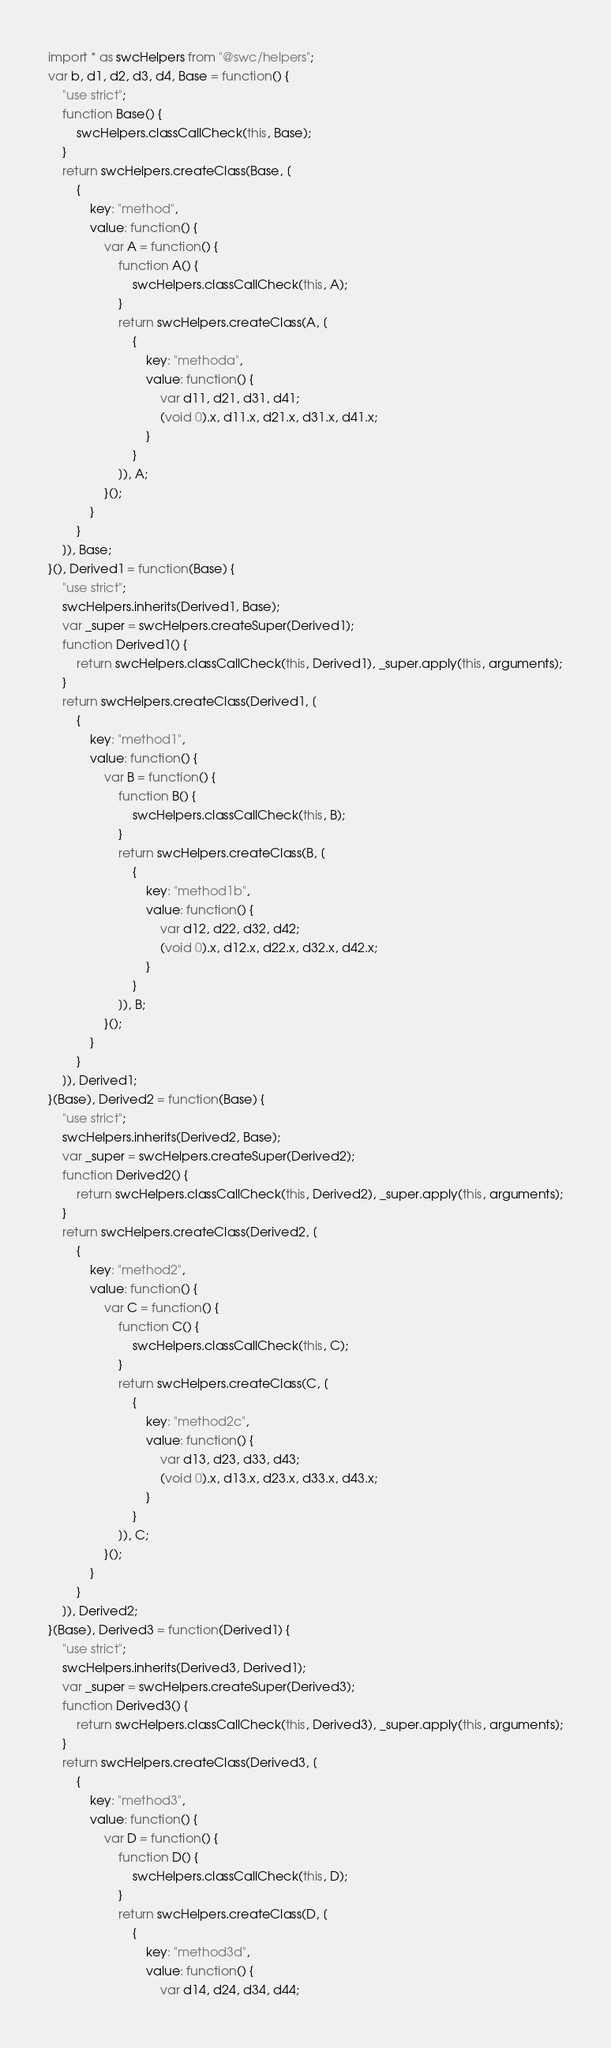Convert code to text. <code><loc_0><loc_0><loc_500><loc_500><_JavaScript_>import * as swcHelpers from "@swc/helpers";
var b, d1, d2, d3, d4, Base = function() {
    "use strict";
    function Base() {
        swcHelpers.classCallCheck(this, Base);
    }
    return swcHelpers.createClass(Base, [
        {
            key: "method",
            value: function() {
                var A = function() {
                    function A() {
                        swcHelpers.classCallCheck(this, A);
                    }
                    return swcHelpers.createClass(A, [
                        {
                            key: "methoda",
                            value: function() {
                                var d11, d21, d31, d41;
                                (void 0).x, d11.x, d21.x, d31.x, d41.x;
                            }
                        }
                    ]), A;
                }();
            }
        }
    ]), Base;
}(), Derived1 = function(Base) {
    "use strict";
    swcHelpers.inherits(Derived1, Base);
    var _super = swcHelpers.createSuper(Derived1);
    function Derived1() {
        return swcHelpers.classCallCheck(this, Derived1), _super.apply(this, arguments);
    }
    return swcHelpers.createClass(Derived1, [
        {
            key: "method1",
            value: function() {
                var B = function() {
                    function B() {
                        swcHelpers.classCallCheck(this, B);
                    }
                    return swcHelpers.createClass(B, [
                        {
                            key: "method1b",
                            value: function() {
                                var d12, d22, d32, d42;
                                (void 0).x, d12.x, d22.x, d32.x, d42.x;
                            }
                        }
                    ]), B;
                }();
            }
        }
    ]), Derived1;
}(Base), Derived2 = function(Base) {
    "use strict";
    swcHelpers.inherits(Derived2, Base);
    var _super = swcHelpers.createSuper(Derived2);
    function Derived2() {
        return swcHelpers.classCallCheck(this, Derived2), _super.apply(this, arguments);
    }
    return swcHelpers.createClass(Derived2, [
        {
            key: "method2",
            value: function() {
                var C = function() {
                    function C() {
                        swcHelpers.classCallCheck(this, C);
                    }
                    return swcHelpers.createClass(C, [
                        {
                            key: "method2c",
                            value: function() {
                                var d13, d23, d33, d43;
                                (void 0).x, d13.x, d23.x, d33.x, d43.x;
                            }
                        }
                    ]), C;
                }();
            }
        }
    ]), Derived2;
}(Base), Derived3 = function(Derived1) {
    "use strict";
    swcHelpers.inherits(Derived3, Derived1);
    var _super = swcHelpers.createSuper(Derived3);
    function Derived3() {
        return swcHelpers.classCallCheck(this, Derived3), _super.apply(this, arguments);
    }
    return swcHelpers.createClass(Derived3, [
        {
            key: "method3",
            value: function() {
                var D = function() {
                    function D() {
                        swcHelpers.classCallCheck(this, D);
                    }
                    return swcHelpers.createClass(D, [
                        {
                            key: "method3d",
                            value: function() {
                                var d14, d24, d34, d44;</code> 